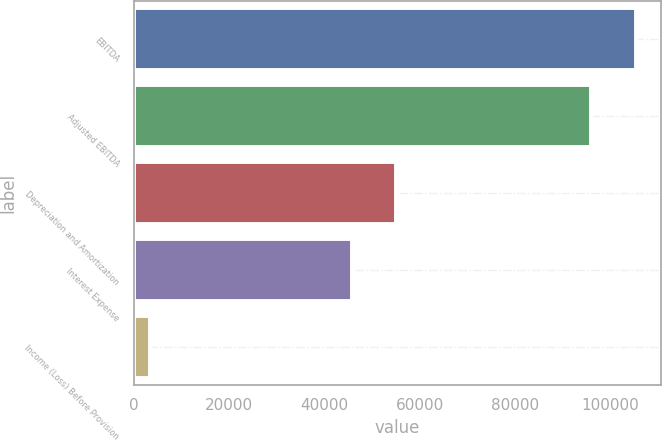Convert chart. <chart><loc_0><loc_0><loc_500><loc_500><bar_chart><fcel>EBITDA<fcel>Adjusted EBITDA<fcel>Depreciation and Amortization<fcel>Interest Expense<fcel>Income (Loss) Before Provision<nl><fcel>105378<fcel>95981<fcel>55070.4<fcel>45673<fcel>3391<nl></chart> 